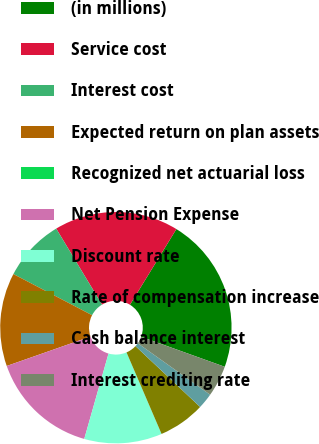<chart> <loc_0><loc_0><loc_500><loc_500><pie_chart><fcel>(in millions)<fcel>Service cost<fcel>Interest cost<fcel>Expected return on plan assets<fcel>Recognized net actuarial loss<fcel>Net Pension Expense<fcel>Discount rate<fcel>Rate of compensation increase<fcel>Cash balance interest<fcel>Interest crediting rate<nl><fcel>21.73%<fcel>17.39%<fcel>8.7%<fcel>13.04%<fcel>0.0%<fcel>15.22%<fcel>10.87%<fcel>6.52%<fcel>2.18%<fcel>4.35%<nl></chart> 